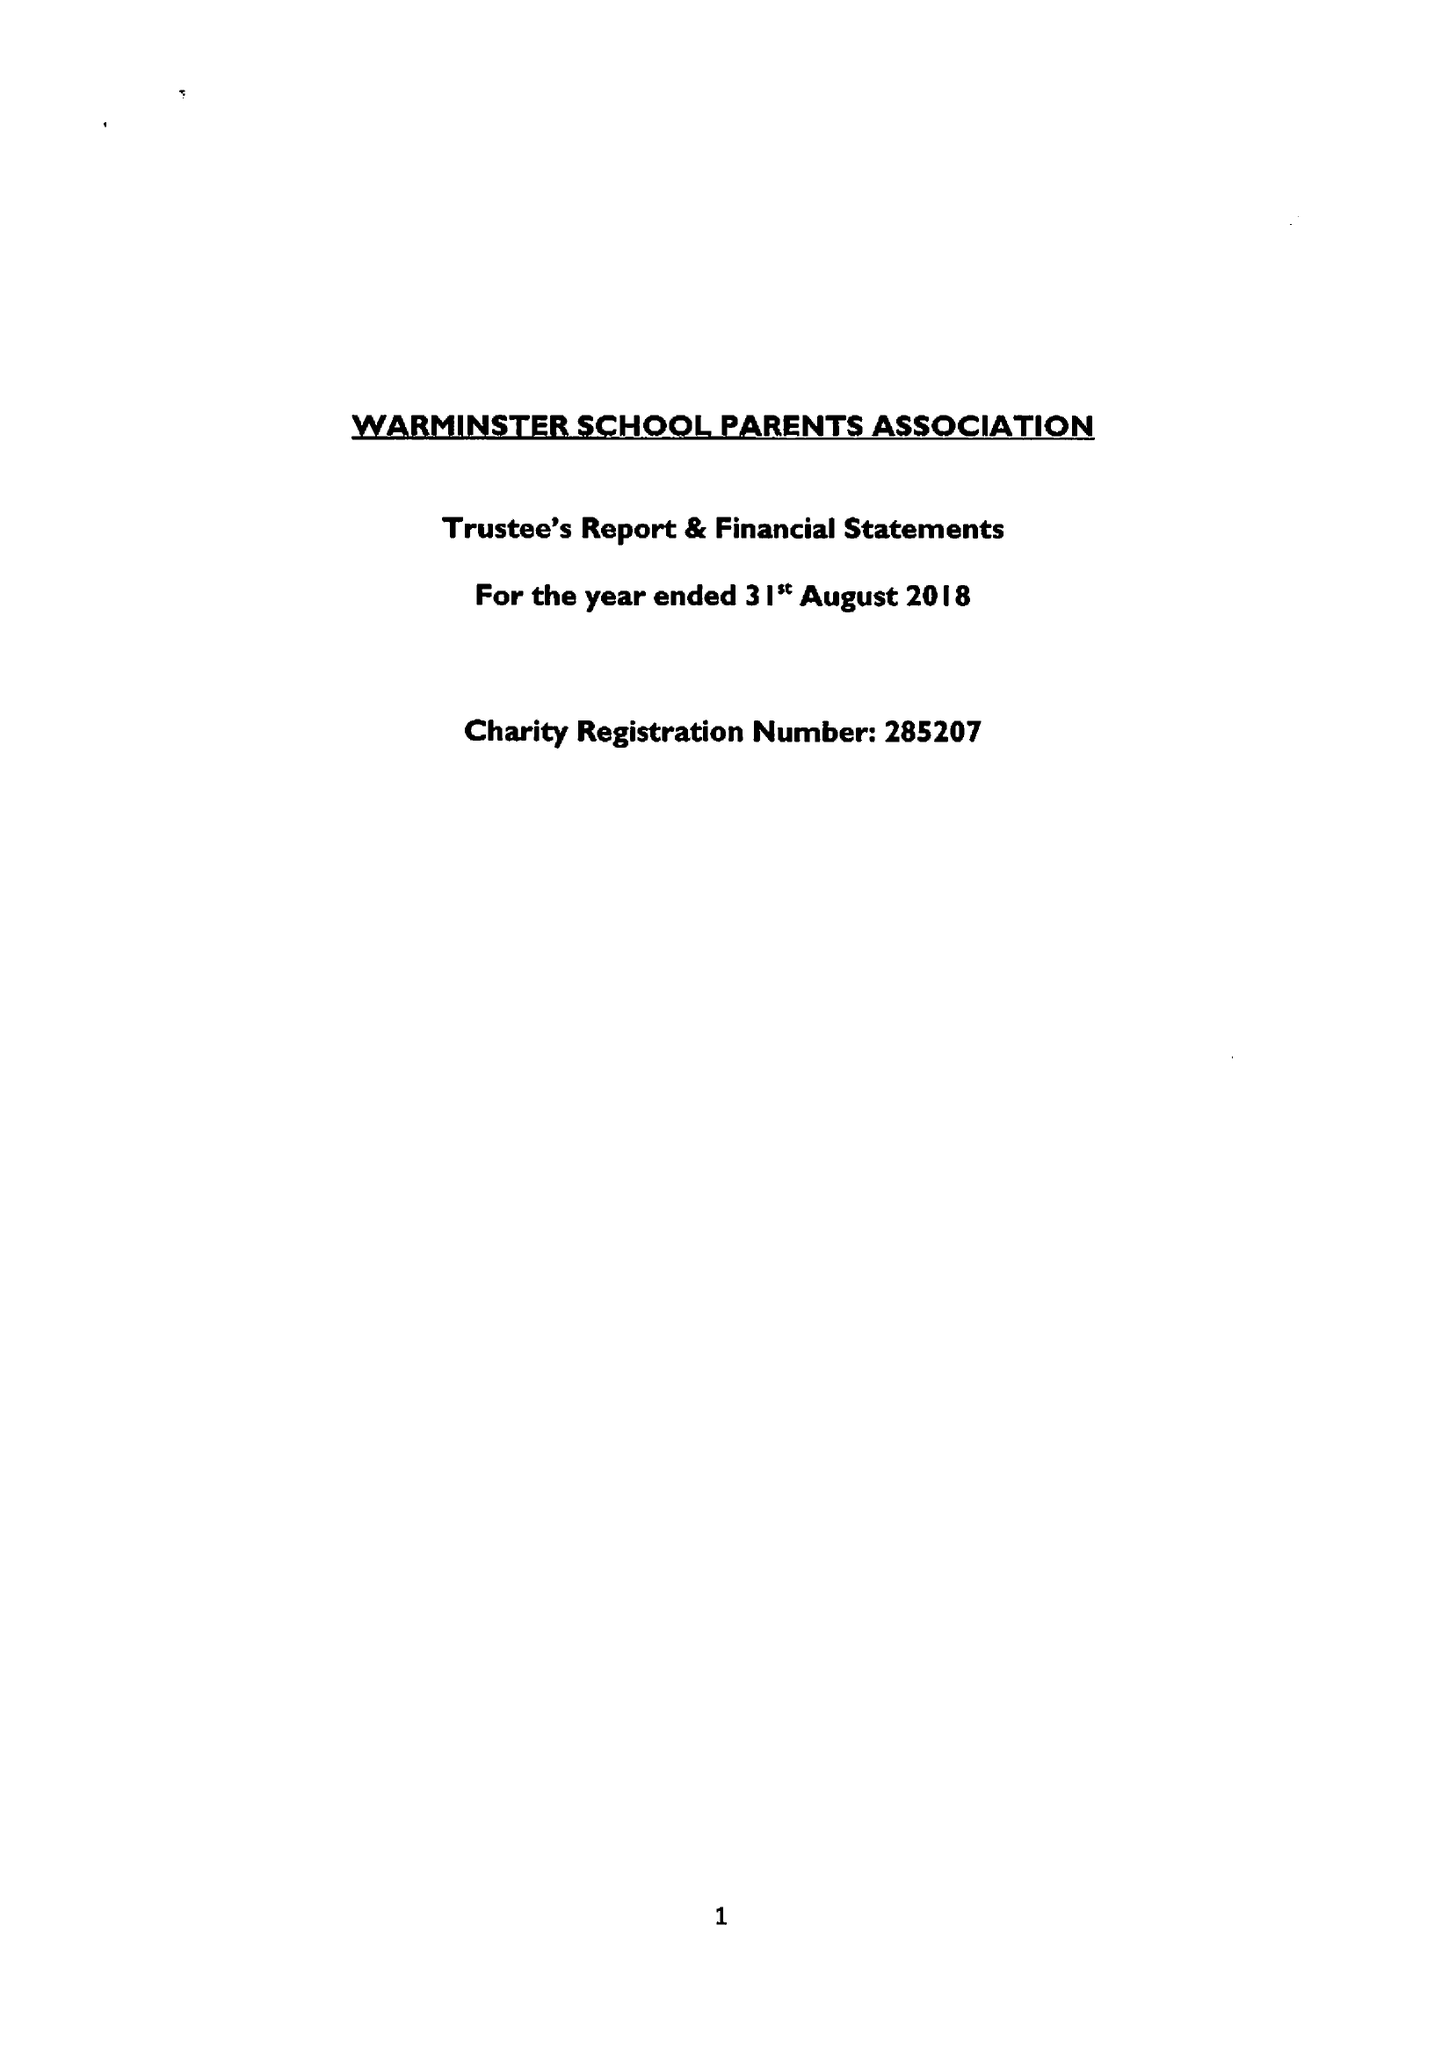What is the value for the charity_number?
Answer the question using a single word or phrase. 285207 